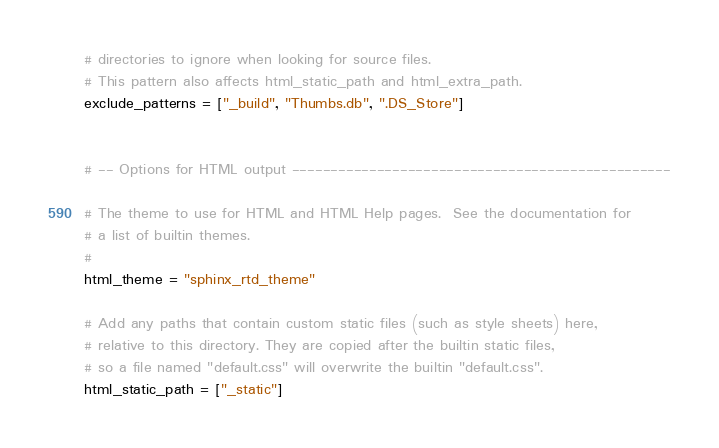Convert code to text. <code><loc_0><loc_0><loc_500><loc_500><_Python_># directories to ignore when looking for source files.
# This pattern also affects html_static_path and html_extra_path.
exclude_patterns = ["_build", "Thumbs.db", ".DS_Store"]


# -- Options for HTML output -------------------------------------------------

# The theme to use for HTML and HTML Help pages.  See the documentation for
# a list of builtin themes.
#
html_theme = "sphinx_rtd_theme"

# Add any paths that contain custom static files (such as style sheets) here,
# relative to this directory. They are copied after the builtin static files,
# so a file named "default.css" will overwrite the builtin "default.css".
html_static_path = ["_static"]
</code> 